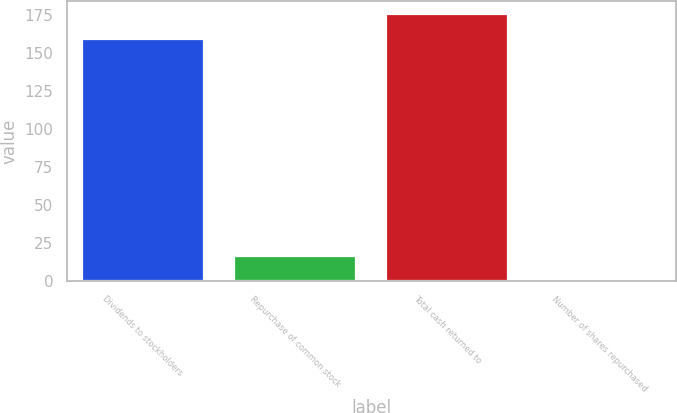Convert chart. <chart><loc_0><loc_0><loc_500><loc_500><bar_chart><fcel>Dividends to stockholders<fcel>Repurchase of common stock<fcel>Total cash returned to<fcel>Number of shares repurchased<nl><fcel>159.5<fcel>16.63<fcel>175.83<fcel>0.3<nl></chart> 